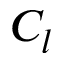<formula> <loc_0><loc_0><loc_500><loc_500>C _ { l }</formula> 